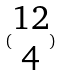Convert formula to latex. <formula><loc_0><loc_0><loc_500><loc_500>( \begin{matrix} 1 2 \\ 4 \end{matrix} )</formula> 